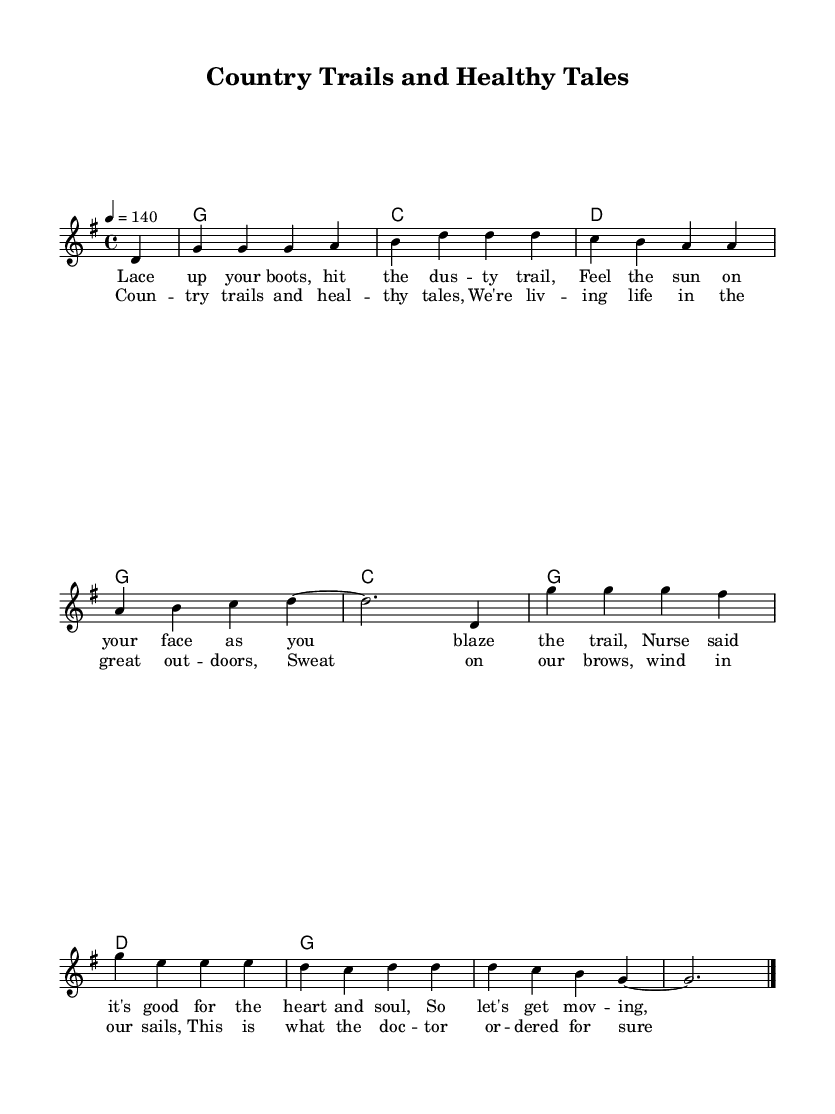What is the key signature of this music? The key signature is G major, which has one sharp (F#). This can be identified by looking at the key signature notation at the beginning of the staff.
Answer: G major What is the time signature of the piece? The time signature is 4/4, which is indicated at the beginning of the music. This means there are four beats in each measure, and the quarter note gets one beat.
Answer: 4/4 What is the tempo marking? The tempo marking indicates a speed of 140 beats per minute, as shown in the tempo indication (4 = 140). This suggests a lively and energetic pace, fitting for a country rock song.
Answer: 140 What is the first line of the lyrics? The first line of the lyrics reads, "Lace up your boots, hit the dusty trail," which reflects the adventurous and outdoor theme of the song. This can be found under the melody staff.
Answer: Lace up your boots, hit the dusty trail How many measures are in the chorus section? Specifically, the chorus section consists of four measures, as indicated by the spacing of the lyrics and the corresponding melodic phrases. Each line of lyrics corresponds to a measure, and counting them confirms this.
Answer: 4 What is the overall theme of the song? The theme centers around fitness and outdoor activities, emphasizing the benefits of exercising in nature. This idea is expressed through the imagery in the lyrics and the energetic feel of the music.
Answer: Fitness and outdoor activities What lifestyle change does the song encourage? The song encourages getting outdoors and being active as a way to improve one's health, aligning with the suggestions from the nurse. The lyrics specifically mention the importance of outdoor activities for heart and soul health.
Answer: Being active outdoors 